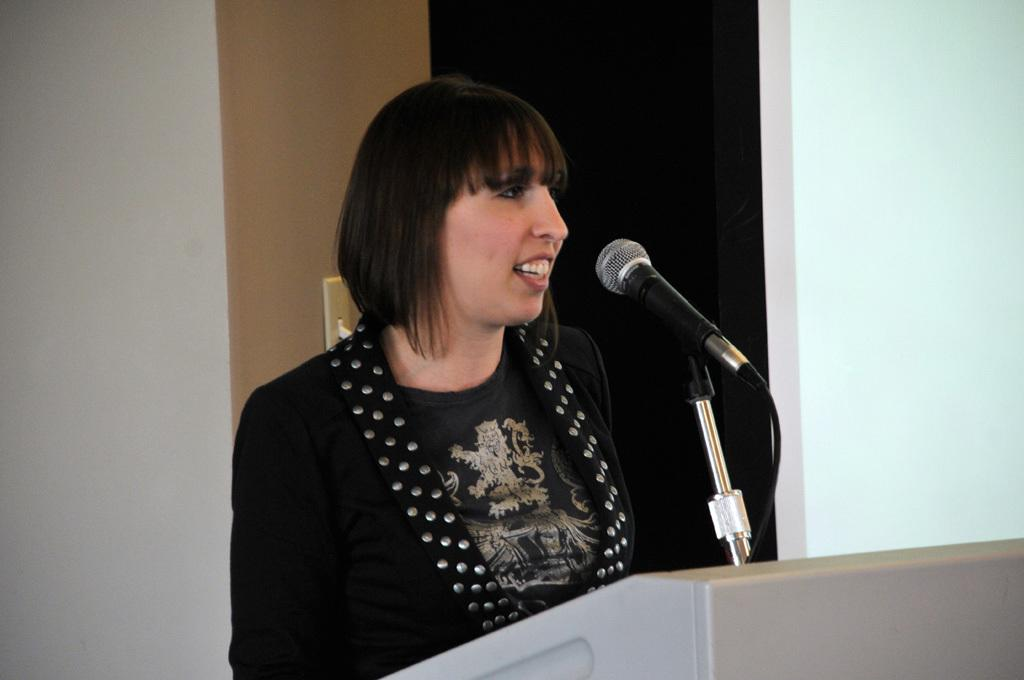Who is the main subject in the image? There is a lady standing in the center of the image. What is the lady standing in front of? There is a podium in front of the lady. What is on the podium? There is a microphone on the podium. What can be seen in the background of the image? There is a wall in the background of the image. How many boys are present in the image? There are no boys present in the image; it features a lady standing in front of a podium with a microphone. What color are the lady's eyes in the image? The lady's eye color cannot be determined from the image, as it does not provide enough detail to make that distinction. 